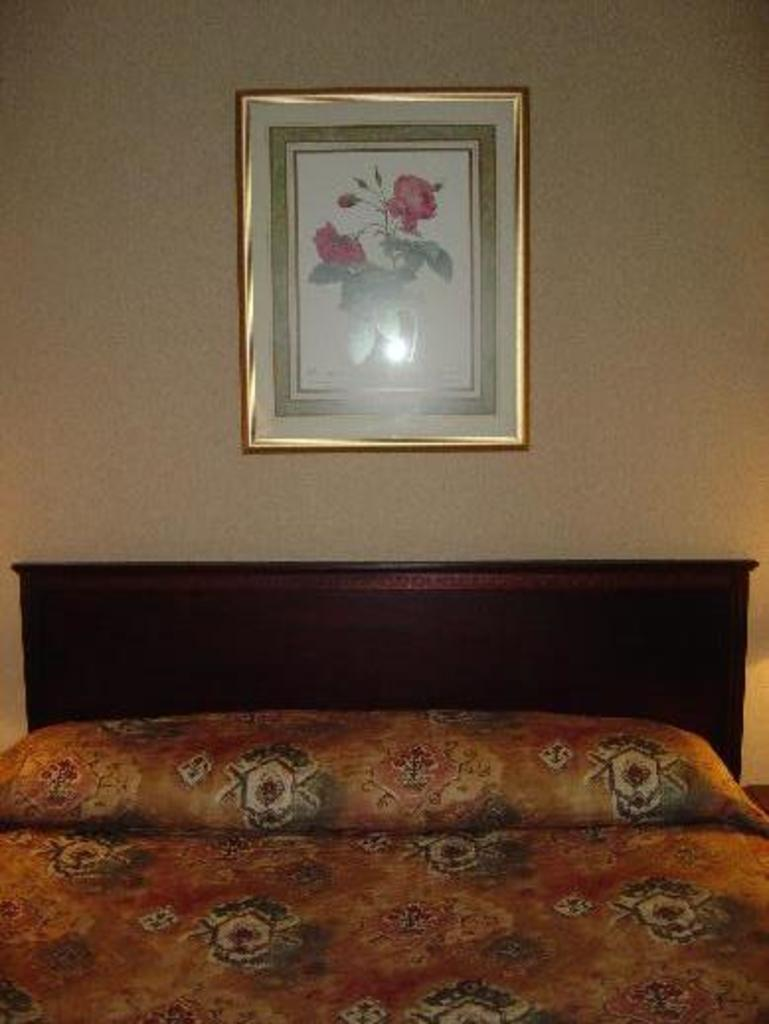What type of furniture is present in the image? There is a bed in the image. What can be seen on the wall in the image? There is a photo frame on the wall in the image. What type of silk is draped over the bed in the image? There is no silk present in the image; it only features a bed and a photo frame on the wall. How many grapes are hanging from the photo frame in the image? There are no grapes present in the image; the photo frame is the only item on the wall. 